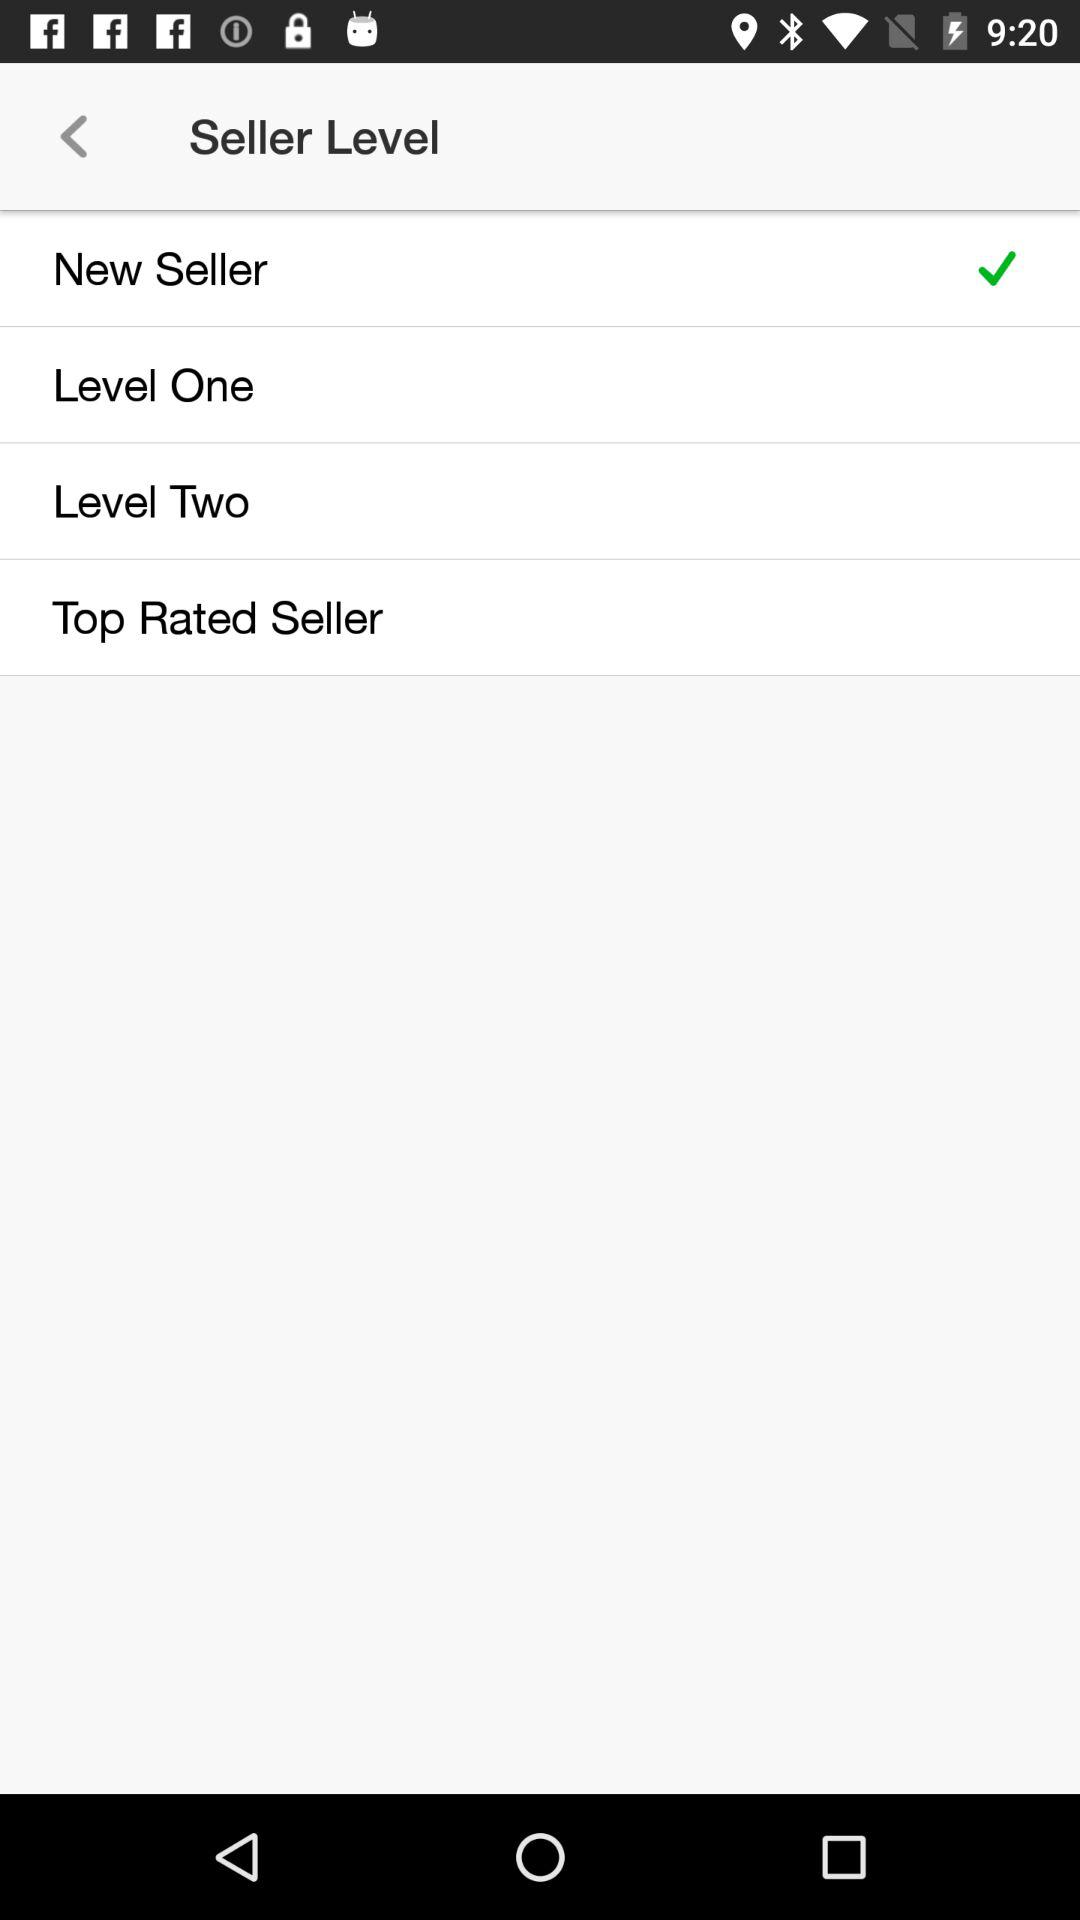How many seller levels are there?
Answer the question using a single word or phrase. 4 